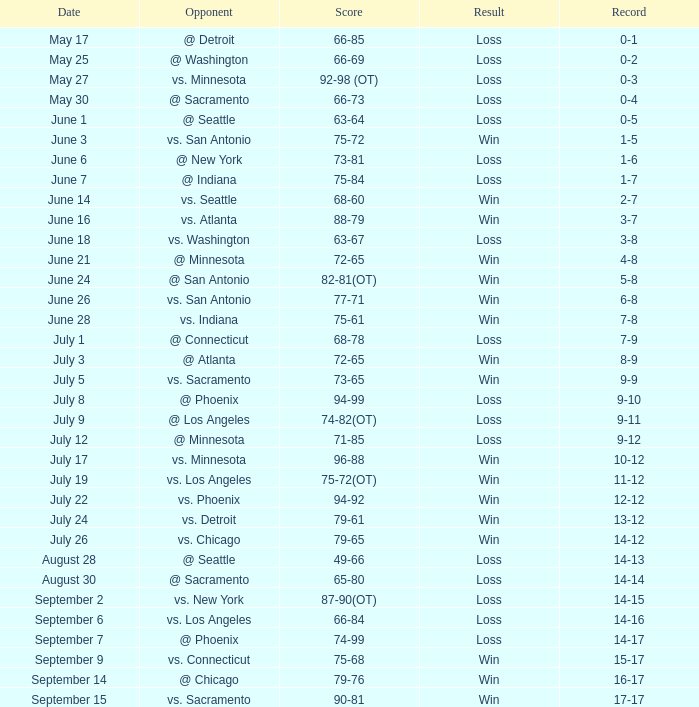What was the Result on July 24? Win. Could you parse the entire table? {'header': ['Date', 'Opponent', 'Score', 'Result', 'Record'], 'rows': [['May 17', '@ Detroit', '66-85', 'Loss', '0-1'], ['May 25', '@ Washington', '66-69', 'Loss', '0-2'], ['May 27', 'vs. Minnesota', '92-98 (OT)', 'Loss', '0-3'], ['May 30', '@ Sacramento', '66-73', 'Loss', '0-4'], ['June 1', '@ Seattle', '63-64', 'Loss', '0-5'], ['June 3', 'vs. San Antonio', '75-72', 'Win', '1-5'], ['June 6', '@ New York', '73-81', 'Loss', '1-6'], ['June 7', '@ Indiana', '75-84', 'Loss', '1-7'], ['June 14', 'vs. Seattle', '68-60', 'Win', '2-7'], ['June 16', 'vs. Atlanta', '88-79', 'Win', '3-7'], ['June 18', 'vs. Washington', '63-67', 'Loss', '3-8'], ['June 21', '@ Minnesota', '72-65', 'Win', '4-8'], ['June 24', '@ San Antonio', '82-81(OT)', 'Win', '5-8'], ['June 26', 'vs. San Antonio', '77-71', 'Win', '6-8'], ['June 28', 'vs. Indiana', '75-61', 'Win', '7-8'], ['July 1', '@ Connecticut', '68-78', 'Loss', '7-9'], ['July 3', '@ Atlanta', '72-65', 'Win', '8-9'], ['July 5', 'vs. Sacramento', '73-65', 'Win', '9-9'], ['July 8', '@ Phoenix', '94-99', 'Loss', '9-10'], ['July 9', '@ Los Angeles', '74-82(OT)', 'Loss', '9-11'], ['July 12', '@ Minnesota', '71-85', 'Loss', '9-12'], ['July 17', 'vs. Minnesota', '96-88', 'Win', '10-12'], ['July 19', 'vs. Los Angeles', '75-72(OT)', 'Win', '11-12'], ['July 22', 'vs. Phoenix', '94-92', 'Win', '12-12'], ['July 24', 'vs. Detroit', '79-61', 'Win', '13-12'], ['July 26', 'vs. Chicago', '79-65', 'Win', '14-12'], ['August 28', '@ Seattle', '49-66', 'Loss', '14-13'], ['August 30', '@ Sacramento', '65-80', 'Loss', '14-14'], ['September 2', 'vs. New York', '87-90(OT)', 'Loss', '14-15'], ['September 6', 'vs. Los Angeles', '66-84', 'Loss', '14-16'], ['September 7', '@ Phoenix', '74-99', 'Loss', '14-17'], ['September 9', 'vs. Connecticut', '75-68', 'Win', '15-17'], ['September 14', '@ Chicago', '79-76', 'Win', '16-17'], ['September 15', 'vs. Sacramento', '90-81', 'Win', '17-17']]} 